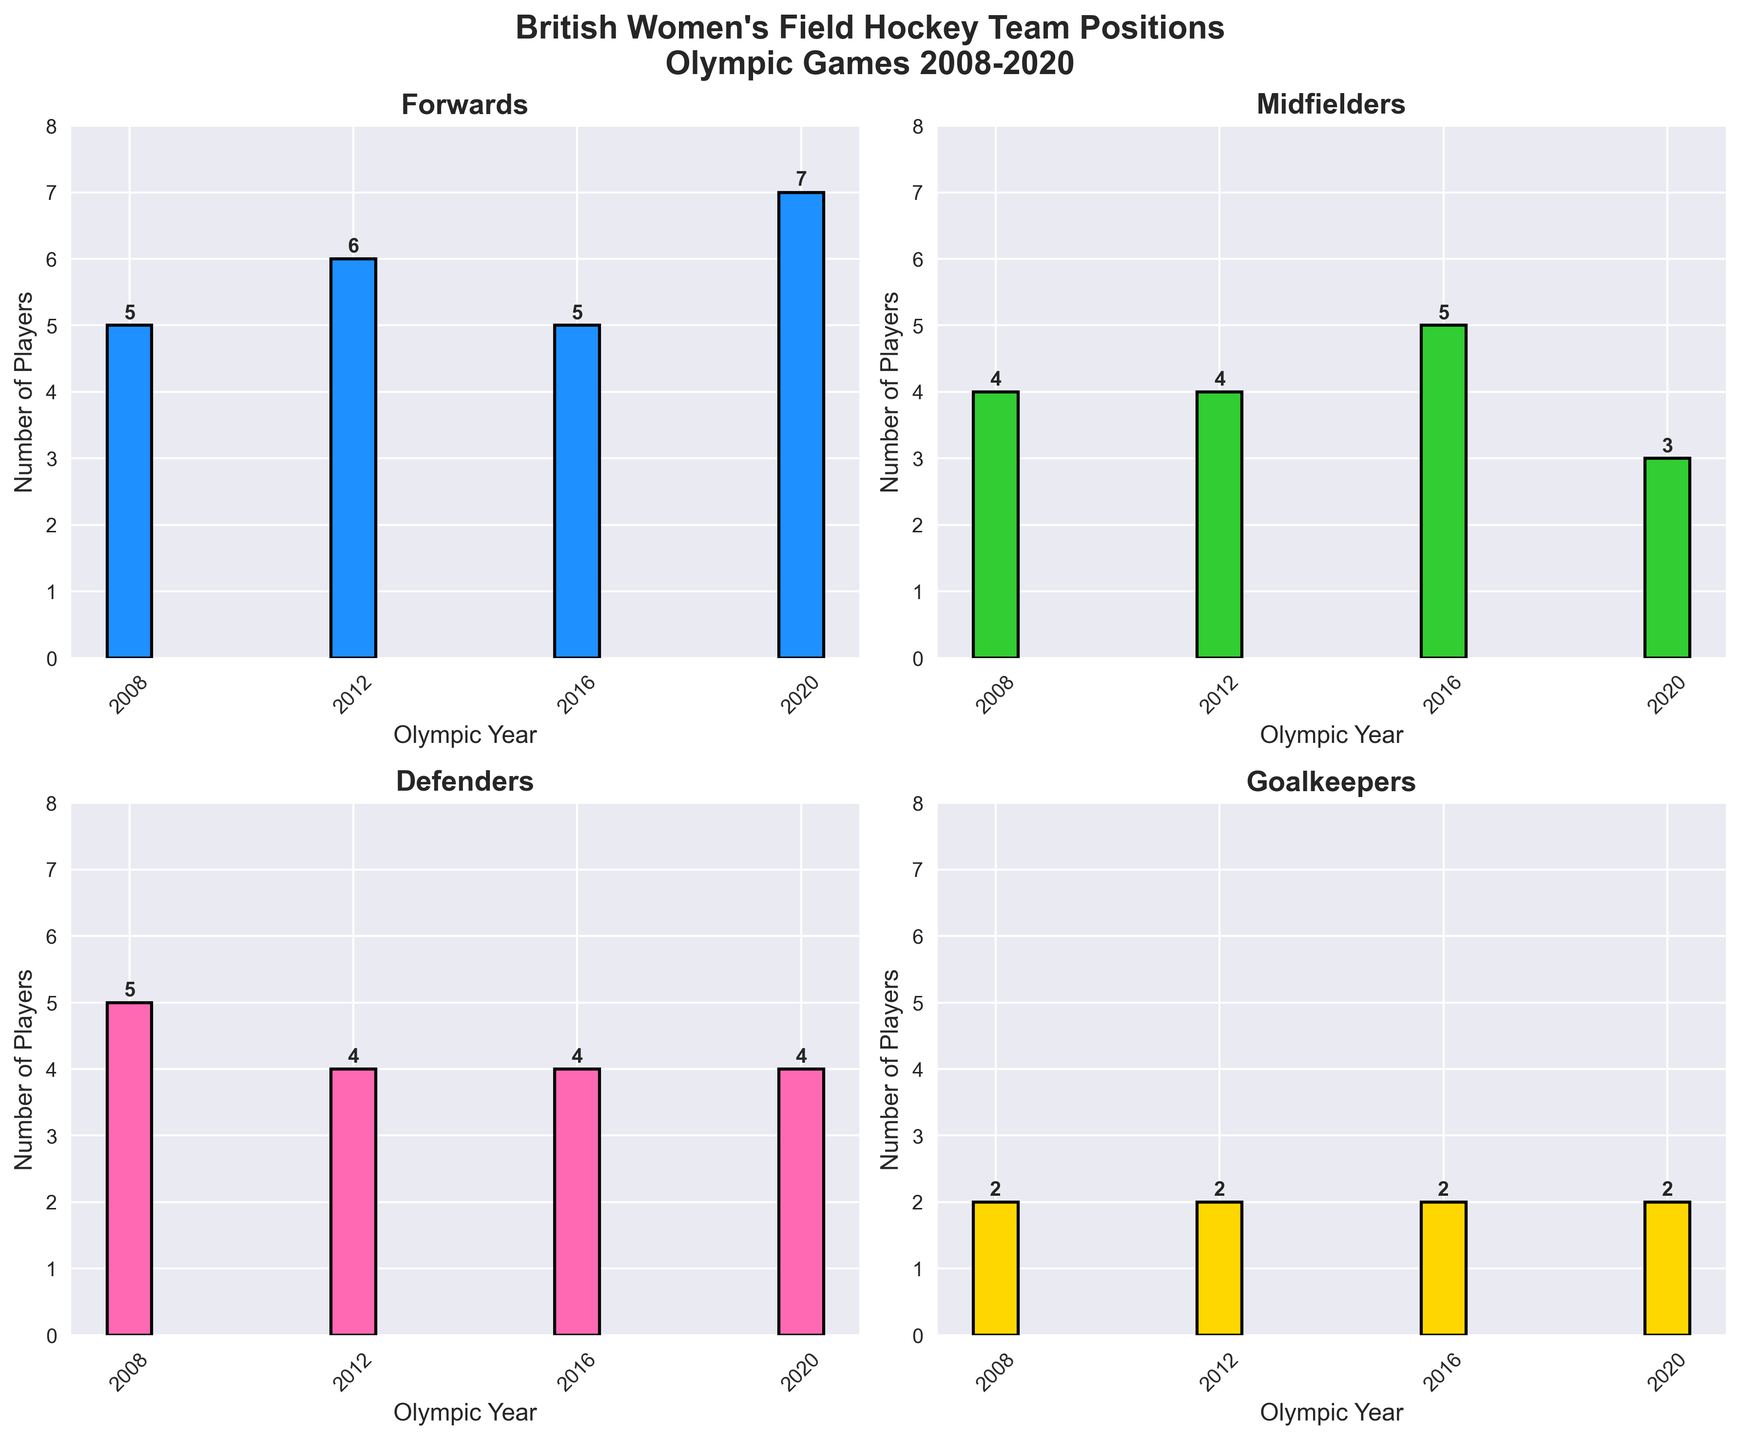What is the total number of Goalkeepers over all the Olympic years? To find the total number of Goalkeepers, sum up the Goalkeepers for each Olympic year: 2 (2008) + 2 (2012) + 2 (2016) + 2 (2020) = 8
Answer: 8 Which Olympic year had the highest number of Forwards? Compare the numbers of Forwards in each Olympic year: 2008 (5), 2012 (6), 2016 (5), 2020 (7). 2020 has the highest number with 7 Forwards
Answer: 2020 How many more Forwards were there in 2020 compared to Midfielders in 2020? Subtract the number of Midfielders in 2020 (3) from the number of Forwards in 2020 (7): 7 - 3 = 4
Answer: 4 Which position had the lowest number of players in 2016? Compare the numbers for each position in 2016: Forward (5), Midfielder (5), Defender (4), Goalkeeper (2). Goalkeeper has the lowest number with 2 players
Answer: Goalkeeper What was the average number of Defenders per Olympic year? Calculate the average number of Defenders by summing up the values and dividing by the number of years: (5 + 4 + 4 + 4) / 4 = 17 / 4 = 4.25
Answer: 4.25 How did the number of Midfielders change from 2008 to 2020? Subtract the number of Midfielders in 2020 (3) from the number in 2008 (4): 3 - 4 = -1. The number decreased by 1
Answer: Decreased by 1 Which position showed the most variation in the number of players across the Olympic years? Look at the difference between the highest and lowest values for each position: Forward (7 - 5 = 2), Midfielder (5 - 3 = 2), Defender (5 - 4 = 1), Goalkeeper (2 - 2 = 0). Both Forward and Midfielder have the most variation with a difference of 2
Answer: Forward and Midfielder How many more Forwards were there in 2016 compared to Goalkeepers in the same year? Subtract the number of Goalkeepers in 2016 (2) from the number of Forwards in 2016 (5): 5 - 2 = 3
Answer: 3 Which positions had an equal number of players in 2012? Compare the numbers for each position in 2012: Forward (6), Midfielder (4), Defender (4), Goalkeeper (2). Midfielder and Defender both had 4 players
Answer: Midfielder and Defender 